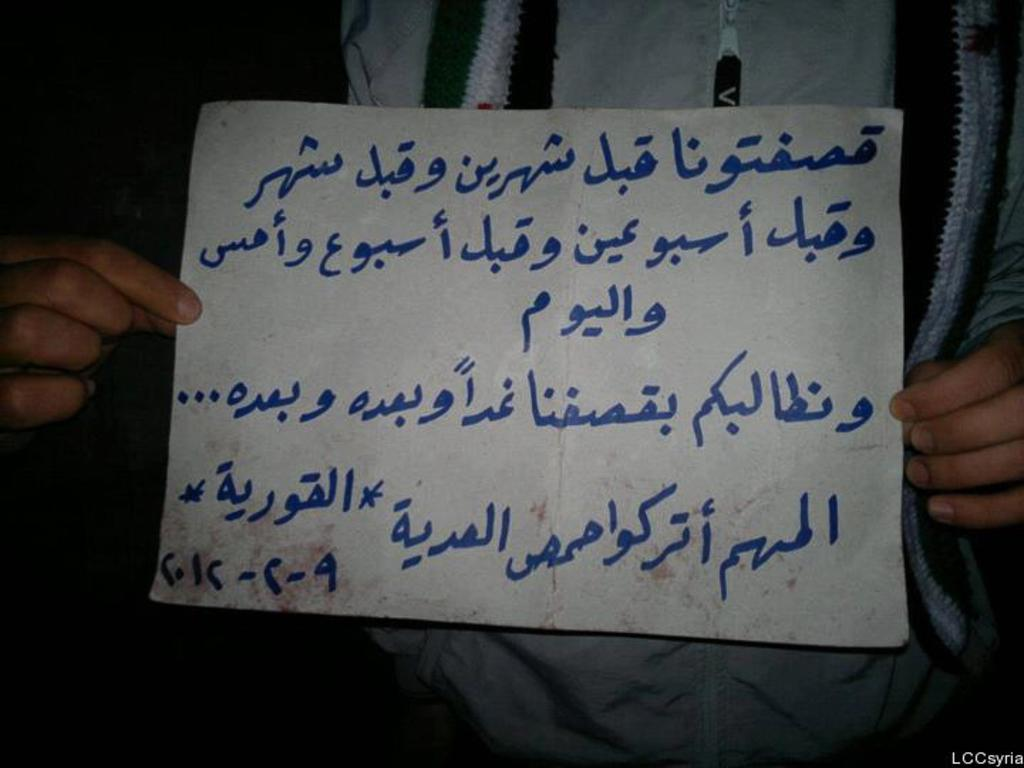What is the person in the image doing? The person in the image is holding a paper. What can be seen on the paper? The paper has writing on it. Can you describe the watermark on the image? The watermark is not visible on the paper, but there is a watermark on the image itself. What type of disease is the person in the image suffering from? There is no indication in the image that the person is suffering from any disease. Can you describe the person's nose in the image? The person's nose is not visible in the image, as the focus is on the paper they are holding. 